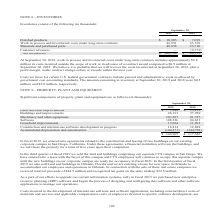According to Cubic's financial document, What is the amount of finished products in 2019? According to the financial document, $10,905 (in thousands). The relevant text states: "Finished products $ 10,905 $ 7,099 Work in process and inventoried costs under long-term contracts 46,951 63,169..." Also, What do the costs incurred for certain U.S. federal government contracts include? general and administrative costs as allowed by government cost accounting standards. The document states: "certain U.S. federal government contracts include general and administrative costs as allowed by government cost accounting standards. The amounts rem..." Also, What are the components that make up the net inventories? The document contains multiple relevant values: Finished products, Work in process and inventoried costs under long-term contracts, Materials and purchased parts, Customer advances. From the document: "Finished products $ 10,905 $ 7,099 Work in process and inventoried costs under long-term contracts 46,951 63,169 Materials and purchased parts 48,938 ..." Additionally, In which year is the value of finished products higher? According to the financial document, 2019. The relevant text states: "September 30, 2019 2018..." Also, can you calculate: What is the change in materials and purchased parts from 2018 to 2019? Based on the calculation: 48,938-23,710, the result is 25228 (in thousands). This is based on the information: "Materials and purchased parts 48,938 23,710 Customer advances — (9,779) Materials and purchased parts 48,938 23,710 Customer advances — (9,779)..." The key data points involved are: 23,710, 48,938. Also, can you calculate: What is the percentage change in net inventories from 2018 to 2019? To answer this question, I need to perform calculations using the financial data. The calculation is: (106,794-84,199)/84,199, which equals 26.84 (percentage). This is based on the information: "Net inventories $ 106,794 $ 84,199 Net inventories $ 106,794 $ 84,199..." The key data points involved are: 106,794, 84,199. 